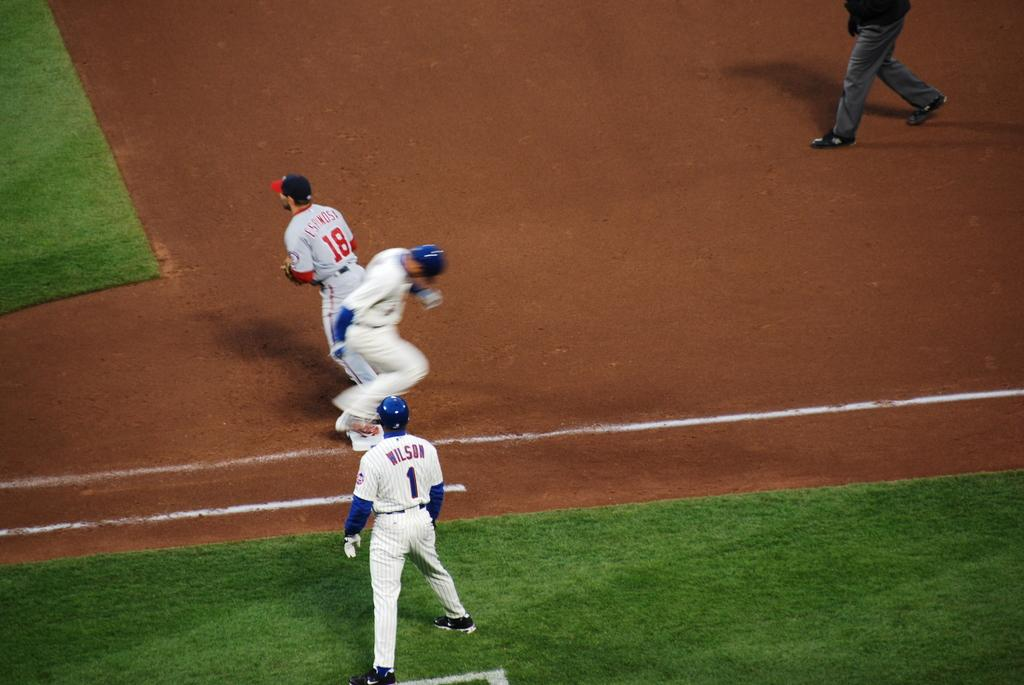<image>
Provide a brief description of the given image. First base coach Wilson watched as his player safely crosses first base. 